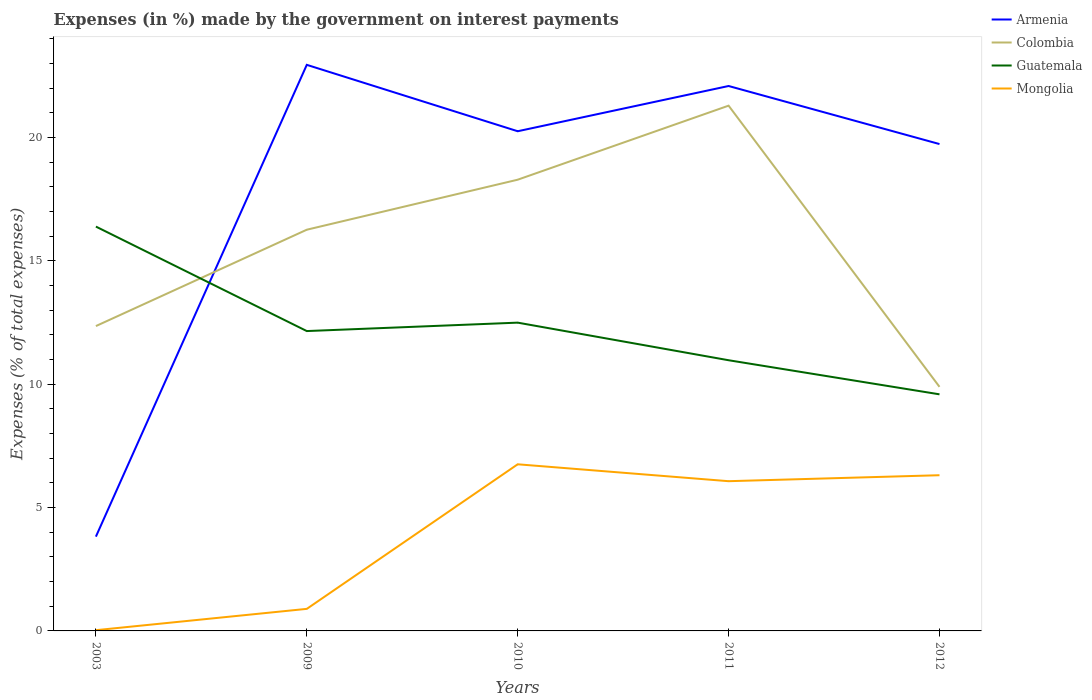Is the number of lines equal to the number of legend labels?
Your response must be concise. Yes. Across all years, what is the maximum percentage of expenses made by the government on interest payments in Colombia?
Offer a very short reply. 9.89. What is the total percentage of expenses made by the government on interest payments in Mongolia in the graph?
Give a very brief answer. -6.04. What is the difference between the highest and the second highest percentage of expenses made by the government on interest payments in Mongolia?
Provide a short and direct response. 6.72. What is the difference between the highest and the lowest percentage of expenses made by the government on interest payments in Mongolia?
Your answer should be very brief. 3. Is the percentage of expenses made by the government on interest payments in Mongolia strictly greater than the percentage of expenses made by the government on interest payments in Armenia over the years?
Provide a short and direct response. Yes. What is the difference between two consecutive major ticks on the Y-axis?
Offer a very short reply. 5. Does the graph contain any zero values?
Provide a succinct answer. No. Does the graph contain grids?
Offer a terse response. No. How are the legend labels stacked?
Your response must be concise. Vertical. What is the title of the graph?
Make the answer very short. Expenses (in %) made by the government on interest payments. What is the label or title of the X-axis?
Keep it short and to the point. Years. What is the label or title of the Y-axis?
Your answer should be very brief. Expenses (% of total expenses). What is the Expenses (% of total expenses) in Armenia in 2003?
Give a very brief answer. 3.82. What is the Expenses (% of total expenses) of Colombia in 2003?
Your answer should be very brief. 12.36. What is the Expenses (% of total expenses) of Guatemala in 2003?
Your answer should be compact. 16.39. What is the Expenses (% of total expenses) of Mongolia in 2003?
Make the answer very short. 0.03. What is the Expenses (% of total expenses) of Armenia in 2009?
Offer a terse response. 22.94. What is the Expenses (% of total expenses) in Colombia in 2009?
Your answer should be compact. 16.26. What is the Expenses (% of total expenses) of Guatemala in 2009?
Offer a terse response. 12.15. What is the Expenses (% of total expenses) in Mongolia in 2009?
Provide a short and direct response. 0.89. What is the Expenses (% of total expenses) in Armenia in 2010?
Your response must be concise. 20.25. What is the Expenses (% of total expenses) in Colombia in 2010?
Offer a very short reply. 18.29. What is the Expenses (% of total expenses) of Guatemala in 2010?
Your response must be concise. 12.5. What is the Expenses (% of total expenses) in Mongolia in 2010?
Your answer should be very brief. 6.75. What is the Expenses (% of total expenses) in Armenia in 2011?
Your response must be concise. 22.09. What is the Expenses (% of total expenses) in Colombia in 2011?
Your answer should be very brief. 21.29. What is the Expenses (% of total expenses) of Guatemala in 2011?
Ensure brevity in your answer.  10.97. What is the Expenses (% of total expenses) in Mongolia in 2011?
Give a very brief answer. 6.07. What is the Expenses (% of total expenses) in Armenia in 2012?
Keep it short and to the point. 19.73. What is the Expenses (% of total expenses) in Colombia in 2012?
Your answer should be compact. 9.89. What is the Expenses (% of total expenses) of Guatemala in 2012?
Provide a succinct answer. 9.59. What is the Expenses (% of total expenses) of Mongolia in 2012?
Your response must be concise. 6.31. Across all years, what is the maximum Expenses (% of total expenses) of Armenia?
Your answer should be very brief. 22.94. Across all years, what is the maximum Expenses (% of total expenses) of Colombia?
Your response must be concise. 21.29. Across all years, what is the maximum Expenses (% of total expenses) of Guatemala?
Your answer should be very brief. 16.39. Across all years, what is the maximum Expenses (% of total expenses) in Mongolia?
Ensure brevity in your answer.  6.75. Across all years, what is the minimum Expenses (% of total expenses) in Armenia?
Your answer should be compact. 3.82. Across all years, what is the minimum Expenses (% of total expenses) of Colombia?
Offer a terse response. 9.89. Across all years, what is the minimum Expenses (% of total expenses) of Guatemala?
Make the answer very short. 9.59. Across all years, what is the minimum Expenses (% of total expenses) of Mongolia?
Provide a short and direct response. 0.03. What is the total Expenses (% of total expenses) of Armenia in the graph?
Give a very brief answer. 88.84. What is the total Expenses (% of total expenses) of Colombia in the graph?
Provide a succinct answer. 78.09. What is the total Expenses (% of total expenses) of Guatemala in the graph?
Your answer should be very brief. 61.6. What is the total Expenses (% of total expenses) in Mongolia in the graph?
Your answer should be compact. 20.06. What is the difference between the Expenses (% of total expenses) in Armenia in 2003 and that in 2009?
Your answer should be compact. -19.12. What is the difference between the Expenses (% of total expenses) of Colombia in 2003 and that in 2009?
Give a very brief answer. -3.91. What is the difference between the Expenses (% of total expenses) in Guatemala in 2003 and that in 2009?
Make the answer very short. 4.23. What is the difference between the Expenses (% of total expenses) in Mongolia in 2003 and that in 2009?
Provide a short and direct response. -0.86. What is the difference between the Expenses (% of total expenses) in Armenia in 2003 and that in 2010?
Make the answer very short. -16.43. What is the difference between the Expenses (% of total expenses) in Colombia in 2003 and that in 2010?
Your response must be concise. -5.93. What is the difference between the Expenses (% of total expenses) in Guatemala in 2003 and that in 2010?
Offer a terse response. 3.89. What is the difference between the Expenses (% of total expenses) of Mongolia in 2003 and that in 2010?
Offer a very short reply. -6.72. What is the difference between the Expenses (% of total expenses) in Armenia in 2003 and that in 2011?
Your response must be concise. -18.26. What is the difference between the Expenses (% of total expenses) of Colombia in 2003 and that in 2011?
Your response must be concise. -8.93. What is the difference between the Expenses (% of total expenses) in Guatemala in 2003 and that in 2011?
Your answer should be very brief. 5.42. What is the difference between the Expenses (% of total expenses) of Mongolia in 2003 and that in 2011?
Your response must be concise. -6.04. What is the difference between the Expenses (% of total expenses) in Armenia in 2003 and that in 2012?
Give a very brief answer. -15.91. What is the difference between the Expenses (% of total expenses) in Colombia in 2003 and that in 2012?
Provide a succinct answer. 2.46. What is the difference between the Expenses (% of total expenses) of Guatemala in 2003 and that in 2012?
Provide a short and direct response. 6.8. What is the difference between the Expenses (% of total expenses) of Mongolia in 2003 and that in 2012?
Your answer should be compact. -6.28. What is the difference between the Expenses (% of total expenses) in Armenia in 2009 and that in 2010?
Make the answer very short. 2.69. What is the difference between the Expenses (% of total expenses) in Colombia in 2009 and that in 2010?
Make the answer very short. -2.03. What is the difference between the Expenses (% of total expenses) in Guatemala in 2009 and that in 2010?
Your answer should be compact. -0.34. What is the difference between the Expenses (% of total expenses) of Mongolia in 2009 and that in 2010?
Make the answer very short. -5.86. What is the difference between the Expenses (% of total expenses) in Armenia in 2009 and that in 2011?
Keep it short and to the point. 0.86. What is the difference between the Expenses (% of total expenses) in Colombia in 2009 and that in 2011?
Keep it short and to the point. -5.03. What is the difference between the Expenses (% of total expenses) in Guatemala in 2009 and that in 2011?
Your answer should be very brief. 1.18. What is the difference between the Expenses (% of total expenses) of Mongolia in 2009 and that in 2011?
Ensure brevity in your answer.  -5.17. What is the difference between the Expenses (% of total expenses) of Armenia in 2009 and that in 2012?
Ensure brevity in your answer.  3.21. What is the difference between the Expenses (% of total expenses) in Colombia in 2009 and that in 2012?
Your answer should be very brief. 6.37. What is the difference between the Expenses (% of total expenses) in Guatemala in 2009 and that in 2012?
Your response must be concise. 2.56. What is the difference between the Expenses (% of total expenses) in Mongolia in 2009 and that in 2012?
Offer a very short reply. -5.42. What is the difference between the Expenses (% of total expenses) of Armenia in 2010 and that in 2011?
Give a very brief answer. -1.83. What is the difference between the Expenses (% of total expenses) of Colombia in 2010 and that in 2011?
Give a very brief answer. -3. What is the difference between the Expenses (% of total expenses) in Guatemala in 2010 and that in 2011?
Make the answer very short. 1.52. What is the difference between the Expenses (% of total expenses) of Mongolia in 2010 and that in 2011?
Keep it short and to the point. 0.69. What is the difference between the Expenses (% of total expenses) in Armenia in 2010 and that in 2012?
Give a very brief answer. 0.52. What is the difference between the Expenses (% of total expenses) in Colombia in 2010 and that in 2012?
Keep it short and to the point. 8.4. What is the difference between the Expenses (% of total expenses) in Guatemala in 2010 and that in 2012?
Your response must be concise. 2.91. What is the difference between the Expenses (% of total expenses) in Mongolia in 2010 and that in 2012?
Provide a short and direct response. 0.44. What is the difference between the Expenses (% of total expenses) in Armenia in 2011 and that in 2012?
Provide a short and direct response. 2.35. What is the difference between the Expenses (% of total expenses) of Colombia in 2011 and that in 2012?
Offer a very short reply. 11.4. What is the difference between the Expenses (% of total expenses) in Guatemala in 2011 and that in 2012?
Your response must be concise. 1.38. What is the difference between the Expenses (% of total expenses) in Mongolia in 2011 and that in 2012?
Keep it short and to the point. -0.24. What is the difference between the Expenses (% of total expenses) in Armenia in 2003 and the Expenses (% of total expenses) in Colombia in 2009?
Your response must be concise. -12.44. What is the difference between the Expenses (% of total expenses) in Armenia in 2003 and the Expenses (% of total expenses) in Guatemala in 2009?
Offer a very short reply. -8.33. What is the difference between the Expenses (% of total expenses) of Armenia in 2003 and the Expenses (% of total expenses) of Mongolia in 2009?
Offer a terse response. 2.93. What is the difference between the Expenses (% of total expenses) in Colombia in 2003 and the Expenses (% of total expenses) in Guatemala in 2009?
Provide a short and direct response. 0.2. What is the difference between the Expenses (% of total expenses) in Colombia in 2003 and the Expenses (% of total expenses) in Mongolia in 2009?
Make the answer very short. 11.46. What is the difference between the Expenses (% of total expenses) in Guatemala in 2003 and the Expenses (% of total expenses) in Mongolia in 2009?
Offer a very short reply. 15.49. What is the difference between the Expenses (% of total expenses) of Armenia in 2003 and the Expenses (% of total expenses) of Colombia in 2010?
Provide a short and direct response. -14.47. What is the difference between the Expenses (% of total expenses) of Armenia in 2003 and the Expenses (% of total expenses) of Guatemala in 2010?
Offer a very short reply. -8.67. What is the difference between the Expenses (% of total expenses) of Armenia in 2003 and the Expenses (% of total expenses) of Mongolia in 2010?
Your response must be concise. -2.93. What is the difference between the Expenses (% of total expenses) in Colombia in 2003 and the Expenses (% of total expenses) in Guatemala in 2010?
Keep it short and to the point. -0.14. What is the difference between the Expenses (% of total expenses) in Colombia in 2003 and the Expenses (% of total expenses) in Mongolia in 2010?
Make the answer very short. 5.6. What is the difference between the Expenses (% of total expenses) in Guatemala in 2003 and the Expenses (% of total expenses) in Mongolia in 2010?
Offer a very short reply. 9.63. What is the difference between the Expenses (% of total expenses) in Armenia in 2003 and the Expenses (% of total expenses) in Colombia in 2011?
Keep it short and to the point. -17.47. What is the difference between the Expenses (% of total expenses) of Armenia in 2003 and the Expenses (% of total expenses) of Guatemala in 2011?
Offer a terse response. -7.15. What is the difference between the Expenses (% of total expenses) of Armenia in 2003 and the Expenses (% of total expenses) of Mongolia in 2011?
Offer a terse response. -2.25. What is the difference between the Expenses (% of total expenses) in Colombia in 2003 and the Expenses (% of total expenses) in Guatemala in 2011?
Offer a terse response. 1.38. What is the difference between the Expenses (% of total expenses) of Colombia in 2003 and the Expenses (% of total expenses) of Mongolia in 2011?
Your answer should be very brief. 6.29. What is the difference between the Expenses (% of total expenses) in Guatemala in 2003 and the Expenses (% of total expenses) in Mongolia in 2011?
Make the answer very short. 10.32. What is the difference between the Expenses (% of total expenses) in Armenia in 2003 and the Expenses (% of total expenses) in Colombia in 2012?
Give a very brief answer. -6.07. What is the difference between the Expenses (% of total expenses) of Armenia in 2003 and the Expenses (% of total expenses) of Guatemala in 2012?
Provide a succinct answer. -5.77. What is the difference between the Expenses (% of total expenses) of Armenia in 2003 and the Expenses (% of total expenses) of Mongolia in 2012?
Keep it short and to the point. -2.49. What is the difference between the Expenses (% of total expenses) of Colombia in 2003 and the Expenses (% of total expenses) of Guatemala in 2012?
Make the answer very short. 2.77. What is the difference between the Expenses (% of total expenses) in Colombia in 2003 and the Expenses (% of total expenses) in Mongolia in 2012?
Your response must be concise. 6.05. What is the difference between the Expenses (% of total expenses) of Guatemala in 2003 and the Expenses (% of total expenses) of Mongolia in 2012?
Keep it short and to the point. 10.08. What is the difference between the Expenses (% of total expenses) of Armenia in 2009 and the Expenses (% of total expenses) of Colombia in 2010?
Give a very brief answer. 4.66. What is the difference between the Expenses (% of total expenses) in Armenia in 2009 and the Expenses (% of total expenses) in Guatemala in 2010?
Offer a very short reply. 10.45. What is the difference between the Expenses (% of total expenses) in Armenia in 2009 and the Expenses (% of total expenses) in Mongolia in 2010?
Ensure brevity in your answer.  16.19. What is the difference between the Expenses (% of total expenses) in Colombia in 2009 and the Expenses (% of total expenses) in Guatemala in 2010?
Keep it short and to the point. 3.77. What is the difference between the Expenses (% of total expenses) in Colombia in 2009 and the Expenses (% of total expenses) in Mongolia in 2010?
Offer a terse response. 9.51. What is the difference between the Expenses (% of total expenses) of Guatemala in 2009 and the Expenses (% of total expenses) of Mongolia in 2010?
Give a very brief answer. 5.4. What is the difference between the Expenses (% of total expenses) of Armenia in 2009 and the Expenses (% of total expenses) of Colombia in 2011?
Offer a very short reply. 1.65. What is the difference between the Expenses (% of total expenses) in Armenia in 2009 and the Expenses (% of total expenses) in Guatemala in 2011?
Offer a terse response. 11.97. What is the difference between the Expenses (% of total expenses) in Armenia in 2009 and the Expenses (% of total expenses) in Mongolia in 2011?
Your response must be concise. 16.88. What is the difference between the Expenses (% of total expenses) in Colombia in 2009 and the Expenses (% of total expenses) in Guatemala in 2011?
Offer a very short reply. 5.29. What is the difference between the Expenses (% of total expenses) of Colombia in 2009 and the Expenses (% of total expenses) of Mongolia in 2011?
Keep it short and to the point. 10.19. What is the difference between the Expenses (% of total expenses) in Guatemala in 2009 and the Expenses (% of total expenses) in Mongolia in 2011?
Offer a very short reply. 6.08. What is the difference between the Expenses (% of total expenses) in Armenia in 2009 and the Expenses (% of total expenses) in Colombia in 2012?
Provide a short and direct response. 13.05. What is the difference between the Expenses (% of total expenses) in Armenia in 2009 and the Expenses (% of total expenses) in Guatemala in 2012?
Your answer should be very brief. 13.35. What is the difference between the Expenses (% of total expenses) in Armenia in 2009 and the Expenses (% of total expenses) in Mongolia in 2012?
Your answer should be very brief. 16.63. What is the difference between the Expenses (% of total expenses) in Colombia in 2009 and the Expenses (% of total expenses) in Guatemala in 2012?
Keep it short and to the point. 6.67. What is the difference between the Expenses (% of total expenses) in Colombia in 2009 and the Expenses (% of total expenses) in Mongolia in 2012?
Offer a very short reply. 9.95. What is the difference between the Expenses (% of total expenses) of Guatemala in 2009 and the Expenses (% of total expenses) of Mongolia in 2012?
Keep it short and to the point. 5.84. What is the difference between the Expenses (% of total expenses) in Armenia in 2010 and the Expenses (% of total expenses) in Colombia in 2011?
Your response must be concise. -1.04. What is the difference between the Expenses (% of total expenses) of Armenia in 2010 and the Expenses (% of total expenses) of Guatemala in 2011?
Keep it short and to the point. 9.28. What is the difference between the Expenses (% of total expenses) of Armenia in 2010 and the Expenses (% of total expenses) of Mongolia in 2011?
Ensure brevity in your answer.  14.18. What is the difference between the Expenses (% of total expenses) of Colombia in 2010 and the Expenses (% of total expenses) of Guatemala in 2011?
Ensure brevity in your answer.  7.32. What is the difference between the Expenses (% of total expenses) in Colombia in 2010 and the Expenses (% of total expenses) in Mongolia in 2011?
Make the answer very short. 12.22. What is the difference between the Expenses (% of total expenses) in Guatemala in 2010 and the Expenses (% of total expenses) in Mongolia in 2011?
Your answer should be compact. 6.43. What is the difference between the Expenses (% of total expenses) in Armenia in 2010 and the Expenses (% of total expenses) in Colombia in 2012?
Keep it short and to the point. 10.36. What is the difference between the Expenses (% of total expenses) of Armenia in 2010 and the Expenses (% of total expenses) of Guatemala in 2012?
Make the answer very short. 10.66. What is the difference between the Expenses (% of total expenses) in Armenia in 2010 and the Expenses (% of total expenses) in Mongolia in 2012?
Offer a terse response. 13.94. What is the difference between the Expenses (% of total expenses) in Colombia in 2010 and the Expenses (% of total expenses) in Guatemala in 2012?
Provide a succinct answer. 8.7. What is the difference between the Expenses (% of total expenses) of Colombia in 2010 and the Expenses (% of total expenses) of Mongolia in 2012?
Provide a short and direct response. 11.98. What is the difference between the Expenses (% of total expenses) of Guatemala in 2010 and the Expenses (% of total expenses) of Mongolia in 2012?
Give a very brief answer. 6.18. What is the difference between the Expenses (% of total expenses) in Armenia in 2011 and the Expenses (% of total expenses) in Colombia in 2012?
Keep it short and to the point. 12.19. What is the difference between the Expenses (% of total expenses) in Armenia in 2011 and the Expenses (% of total expenses) in Guatemala in 2012?
Give a very brief answer. 12.5. What is the difference between the Expenses (% of total expenses) of Armenia in 2011 and the Expenses (% of total expenses) of Mongolia in 2012?
Your answer should be compact. 15.78. What is the difference between the Expenses (% of total expenses) of Colombia in 2011 and the Expenses (% of total expenses) of Guatemala in 2012?
Provide a short and direct response. 11.7. What is the difference between the Expenses (% of total expenses) of Colombia in 2011 and the Expenses (% of total expenses) of Mongolia in 2012?
Make the answer very short. 14.98. What is the difference between the Expenses (% of total expenses) of Guatemala in 2011 and the Expenses (% of total expenses) of Mongolia in 2012?
Provide a short and direct response. 4.66. What is the average Expenses (% of total expenses) of Armenia per year?
Your answer should be very brief. 17.77. What is the average Expenses (% of total expenses) of Colombia per year?
Make the answer very short. 15.62. What is the average Expenses (% of total expenses) of Guatemala per year?
Keep it short and to the point. 12.32. What is the average Expenses (% of total expenses) in Mongolia per year?
Ensure brevity in your answer.  4.01. In the year 2003, what is the difference between the Expenses (% of total expenses) in Armenia and Expenses (% of total expenses) in Colombia?
Offer a terse response. -8.53. In the year 2003, what is the difference between the Expenses (% of total expenses) in Armenia and Expenses (% of total expenses) in Guatemala?
Offer a very short reply. -12.57. In the year 2003, what is the difference between the Expenses (% of total expenses) of Armenia and Expenses (% of total expenses) of Mongolia?
Keep it short and to the point. 3.79. In the year 2003, what is the difference between the Expenses (% of total expenses) of Colombia and Expenses (% of total expenses) of Guatemala?
Provide a short and direct response. -4.03. In the year 2003, what is the difference between the Expenses (% of total expenses) of Colombia and Expenses (% of total expenses) of Mongolia?
Offer a terse response. 12.33. In the year 2003, what is the difference between the Expenses (% of total expenses) in Guatemala and Expenses (% of total expenses) in Mongolia?
Your response must be concise. 16.36. In the year 2009, what is the difference between the Expenses (% of total expenses) in Armenia and Expenses (% of total expenses) in Colombia?
Your answer should be very brief. 6.68. In the year 2009, what is the difference between the Expenses (% of total expenses) of Armenia and Expenses (% of total expenses) of Guatemala?
Ensure brevity in your answer.  10.79. In the year 2009, what is the difference between the Expenses (% of total expenses) of Armenia and Expenses (% of total expenses) of Mongolia?
Make the answer very short. 22.05. In the year 2009, what is the difference between the Expenses (% of total expenses) of Colombia and Expenses (% of total expenses) of Guatemala?
Provide a short and direct response. 4.11. In the year 2009, what is the difference between the Expenses (% of total expenses) of Colombia and Expenses (% of total expenses) of Mongolia?
Ensure brevity in your answer.  15.37. In the year 2009, what is the difference between the Expenses (% of total expenses) in Guatemala and Expenses (% of total expenses) in Mongolia?
Your answer should be compact. 11.26. In the year 2010, what is the difference between the Expenses (% of total expenses) of Armenia and Expenses (% of total expenses) of Colombia?
Offer a terse response. 1.96. In the year 2010, what is the difference between the Expenses (% of total expenses) in Armenia and Expenses (% of total expenses) in Guatemala?
Your answer should be compact. 7.76. In the year 2010, what is the difference between the Expenses (% of total expenses) in Armenia and Expenses (% of total expenses) in Mongolia?
Keep it short and to the point. 13.5. In the year 2010, what is the difference between the Expenses (% of total expenses) of Colombia and Expenses (% of total expenses) of Guatemala?
Your answer should be compact. 5.79. In the year 2010, what is the difference between the Expenses (% of total expenses) of Colombia and Expenses (% of total expenses) of Mongolia?
Your answer should be very brief. 11.53. In the year 2010, what is the difference between the Expenses (% of total expenses) in Guatemala and Expenses (% of total expenses) in Mongolia?
Give a very brief answer. 5.74. In the year 2011, what is the difference between the Expenses (% of total expenses) in Armenia and Expenses (% of total expenses) in Colombia?
Keep it short and to the point. 0.8. In the year 2011, what is the difference between the Expenses (% of total expenses) in Armenia and Expenses (% of total expenses) in Guatemala?
Give a very brief answer. 11.12. In the year 2011, what is the difference between the Expenses (% of total expenses) in Armenia and Expenses (% of total expenses) in Mongolia?
Provide a short and direct response. 16.02. In the year 2011, what is the difference between the Expenses (% of total expenses) in Colombia and Expenses (% of total expenses) in Guatemala?
Offer a terse response. 10.32. In the year 2011, what is the difference between the Expenses (% of total expenses) in Colombia and Expenses (% of total expenses) in Mongolia?
Offer a very short reply. 15.22. In the year 2011, what is the difference between the Expenses (% of total expenses) of Guatemala and Expenses (% of total expenses) of Mongolia?
Your response must be concise. 4.9. In the year 2012, what is the difference between the Expenses (% of total expenses) of Armenia and Expenses (% of total expenses) of Colombia?
Your answer should be very brief. 9.84. In the year 2012, what is the difference between the Expenses (% of total expenses) of Armenia and Expenses (% of total expenses) of Guatemala?
Offer a very short reply. 10.14. In the year 2012, what is the difference between the Expenses (% of total expenses) of Armenia and Expenses (% of total expenses) of Mongolia?
Ensure brevity in your answer.  13.42. In the year 2012, what is the difference between the Expenses (% of total expenses) in Colombia and Expenses (% of total expenses) in Guatemala?
Give a very brief answer. 0.3. In the year 2012, what is the difference between the Expenses (% of total expenses) of Colombia and Expenses (% of total expenses) of Mongolia?
Provide a succinct answer. 3.58. In the year 2012, what is the difference between the Expenses (% of total expenses) of Guatemala and Expenses (% of total expenses) of Mongolia?
Ensure brevity in your answer.  3.28. What is the ratio of the Expenses (% of total expenses) of Armenia in 2003 to that in 2009?
Your answer should be compact. 0.17. What is the ratio of the Expenses (% of total expenses) in Colombia in 2003 to that in 2009?
Your answer should be very brief. 0.76. What is the ratio of the Expenses (% of total expenses) in Guatemala in 2003 to that in 2009?
Ensure brevity in your answer.  1.35. What is the ratio of the Expenses (% of total expenses) of Mongolia in 2003 to that in 2009?
Ensure brevity in your answer.  0.03. What is the ratio of the Expenses (% of total expenses) in Armenia in 2003 to that in 2010?
Keep it short and to the point. 0.19. What is the ratio of the Expenses (% of total expenses) in Colombia in 2003 to that in 2010?
Ensure brevity in your answer.  0.68. What is the ratio of the Expenses (% of total expenses) of Guatemala in 2003 to that in 2010?
Ensure brevity in your answer.  1.31. What is the ratio of the Expenses (% of total expenses) of Mongolia in 2003 to that in 2010?
Provide a succinct answer. 0. What is the ratio of the Expenses (% of total expenses) of Armenia in 2003 to that in 2011?
Your response must be concise. 0.17. What is the ratio of the Expenses (% of total expenses) in Colombia in 2003 to that in 2011?
Your answer should be compact. 0.58. What is the ratio of the Expenses (% of total expenses) in Guatemala in 2003 to that in 2011?
Offer a very short reply. 1.49. What is the ratio of the Expenses (% of total expenses) in Mongolia in 2003 to that in 2011?
Keep it short and to the point. 0. What is the ratio of the Expenses (% of total expenses) of Armenia in 2003 to that in 2012?
Offer a very short reply. 0.19. What is the ratio of the Expenses (% of total expenses) of Colombia in 2003 to that in 2012?
Keep it short and to the point. 1.25. What is the ratio of the Expenses (% of total expenses) of Guatemala in 2003 to that in 2012?
Give a very brief answer. 1.71. What is the ratio of the Expenses (% of total expenses) of Mongolia in 2003 to that in 2012?
Your answer should be compact. 0. What is the ratio of the Expenses (% of total expenses) in Armenia in 2009 to that in 2010?
Offer a terse response. 1.13. What is the ratio of the Expenses (% of total expenses) in Colombia in 2009 to that in 2010?
Your answer should be very brief. 0.89. What is the ratio of the Expenses (% of total expenses) of Guatemala in 2009 to that in 2010?
Provide a succinct answer. 0.97. What is the ratio of the Expenses (% of total expenses) in Mongolia in 2009 to that in 2010?
Keep it short and to the point. 0.13. What is the ratio of the Expenses (% of total expenses) in Armenia in 2009 to that in 2011?
Keep it short and to the point. 1.04. What is the ratio of the Expenses (% of total expenses) of Colombia in 2009 to that in 2011?
Give a very brief answer. 0.76. What is the ratio of the Expenses (% of total expenses) of Guatemala in 2009 to that in 2011?
Give a very brief answer. 1.11. What is the ratio of the Expenses (% of total expenses) of Mongolia in 2009 to that in 2011?
Keep it short and to the point. 0.15. What is the ratio of the Expenses (% of total expenses) of Armenia in 2009 to that in 2012?
Ensure brevity in your answer.  1.16. What is the ratio of the Expenses (% of total expenses) of Colombia in 2009 to that in 2012?
Make the answer very short. 1.64. What is the ratio of the Expenses (% of total expenses) in Guatemala in 2009 to that in 2012?
Make the answer very short. 1.27. What is the ratio of the Expenses (% of total expenses) in Mongolia in 2009 to that in 2012?
Offer a very short reply. 0.14. What is the ratio of the Expenses (% of total expenses) in Armenia in 2010 to that in 2011?
Make the answer very short. 0.92. What is the ratio of the Expenses (% of total expenses) in Colombia in 2010 to that in 2011?
Ensure brevity in your answer.  0.86. What is the ratio of the Expenses (% of total expenses) in Guatemala in 2010 to that in 2011?
Ensure brevity in your answer.  1.14. What is the ratio of the Expenses (% of total expenses) of Mongolia in 2010 to that in 2011?
Provide a short and direct response. 1.11. What is the ratio of the Expenses (% of total expenses) of Armenia in 2010 to that in 2012?
Provide a succinct answer. 1.03. What is the ratio of the Expenses (% of total expenses) in Colombia in 2010 to that in 2012?
Offer a very short reply. 1.85. What is the ratio of the Expenses (% of total expenses) in Guatemala in 2010 to that in 2012?
Provide a short and direct response. 1.3. What is the ratio of the Expenses (% of total expenses) of Mongolia in 2010 to that in 2012?
Make the answer very short. 1.07. What is the ratio of the Expenses (% of total expenses) of Armenia in 2011 to that in 2012?
Your answer should be compact. 1.12. What is the ratio of the Expenses (% of total expenses) of Colombia in 2011 to that in 2012?
Provide a short and direct response. 2.15. What is the ratio of the Expenses (% of total expenses) of Guatemala in 2011 to that in 2012?
Offer a very short reply. 1.14. What is the ratio of the Expenses (% of total expenses) of Mongolia in 2011 to that in 2012?
Ensure brevity in your answer.  0.96. What is the difference between the highest and the second highest Expenses (% of total expenses) in Armenia?
Offer a very short reply. 0.86. What is the difference between the highest and the second highest Expenses (% of total expenses) in Colombia?
Keep it short and to the point. 3. What is the difference between the highest and the second highest Expenses (% of total expenses) of Guatemala?
Offer a very short reply. 3.89. What is the difference between the highest and the second highest Expenses (% of total expenses) of Mongolia?
Make the answer very short. 0.44. What is the difference between the highest and the lowest Expenses (% of total expenses) of Armenia?
Provide a short and direct response. 19.12. What is the difference between the highest and the lowest Expenses (% of total expenses) in Colombia?
Your answer should be compact. 11.4. What is the difference between the highest and the lowest Expenses (% of total expenses) in Guatemala?
Provide a succinct answer. 6.8. What is the difference between the highest and the lowest Expenses (% of total expenses) in Mongolia?
Provide a short and direct response. 6.72. 